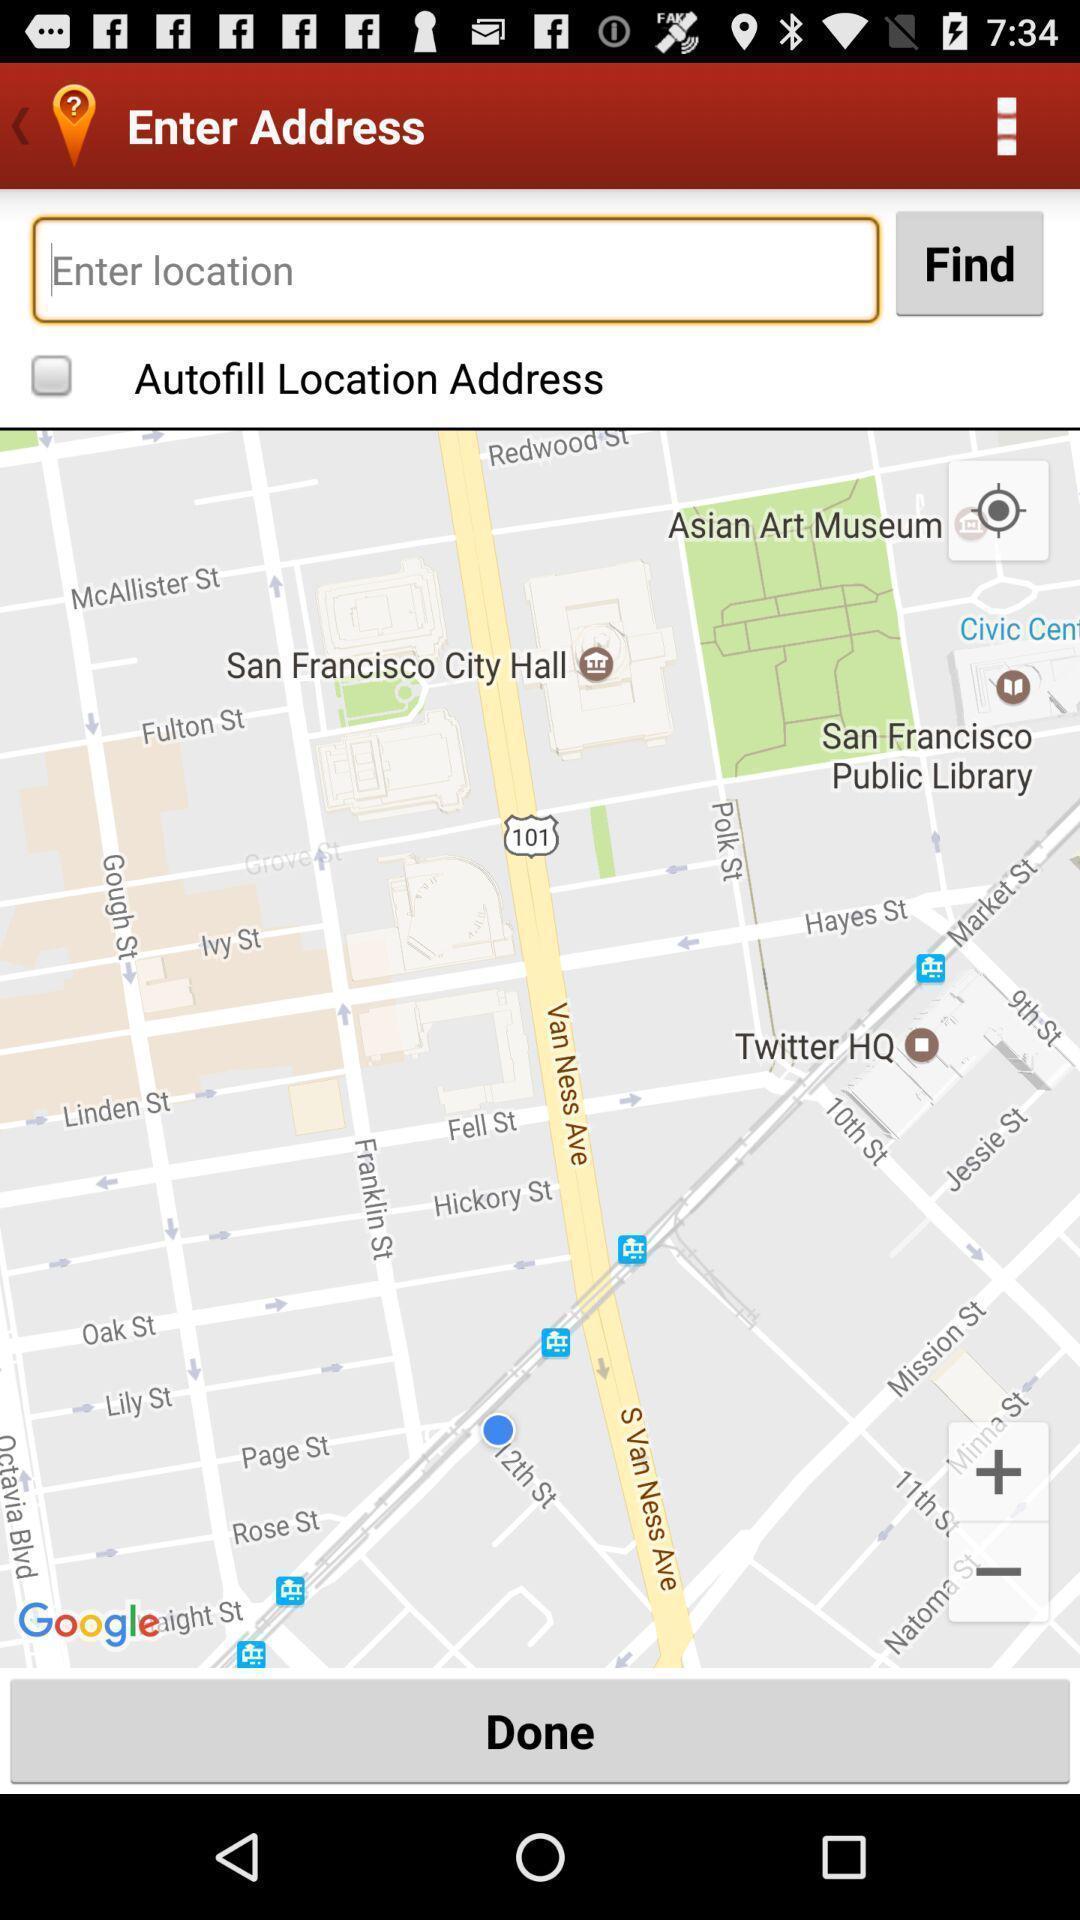Describe the key features of this screenshot. Search bar to find the address location. 